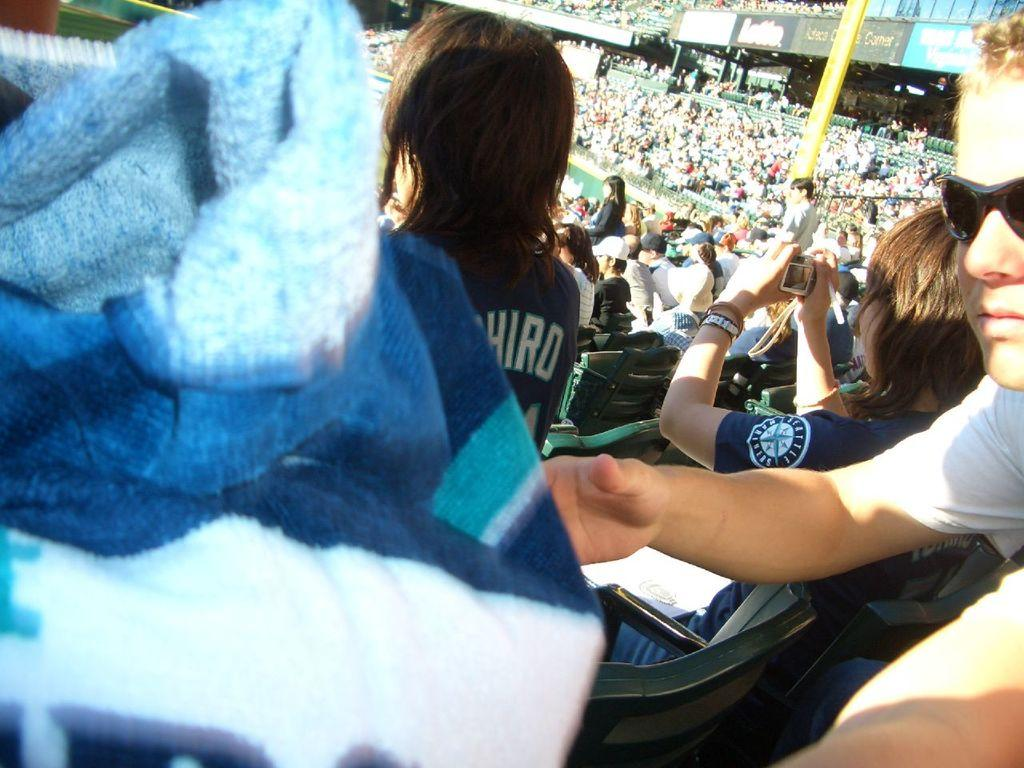What are the people in the image doing? There is a group of people sitting on chairs in the image. What objects can be seen in the image besides the chairs and people? There are boards visible in the image. Who is holding a camera in the image? One person is holding a camera in the image. What color and pattern is the cloth in front of the scene? There is a white and blue color cloth in front of the scene. What type of cracker is being used to prop up the boards in the image? There is no cracker present in the image, and the boards are not being propped up by any object. 